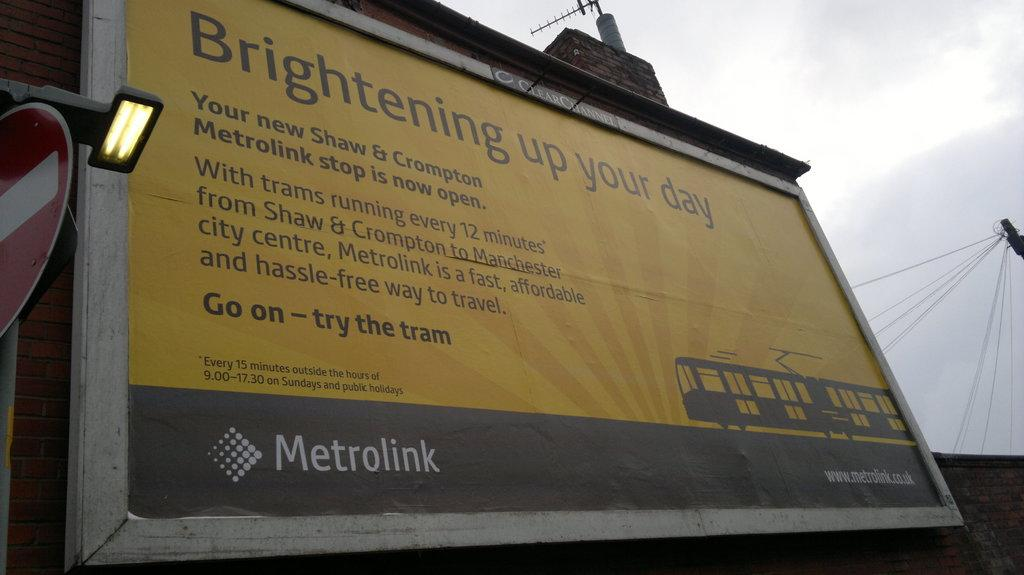<image>
Summarize the visual content of the image. A metrolink billboard is advertising the trains in the area. 